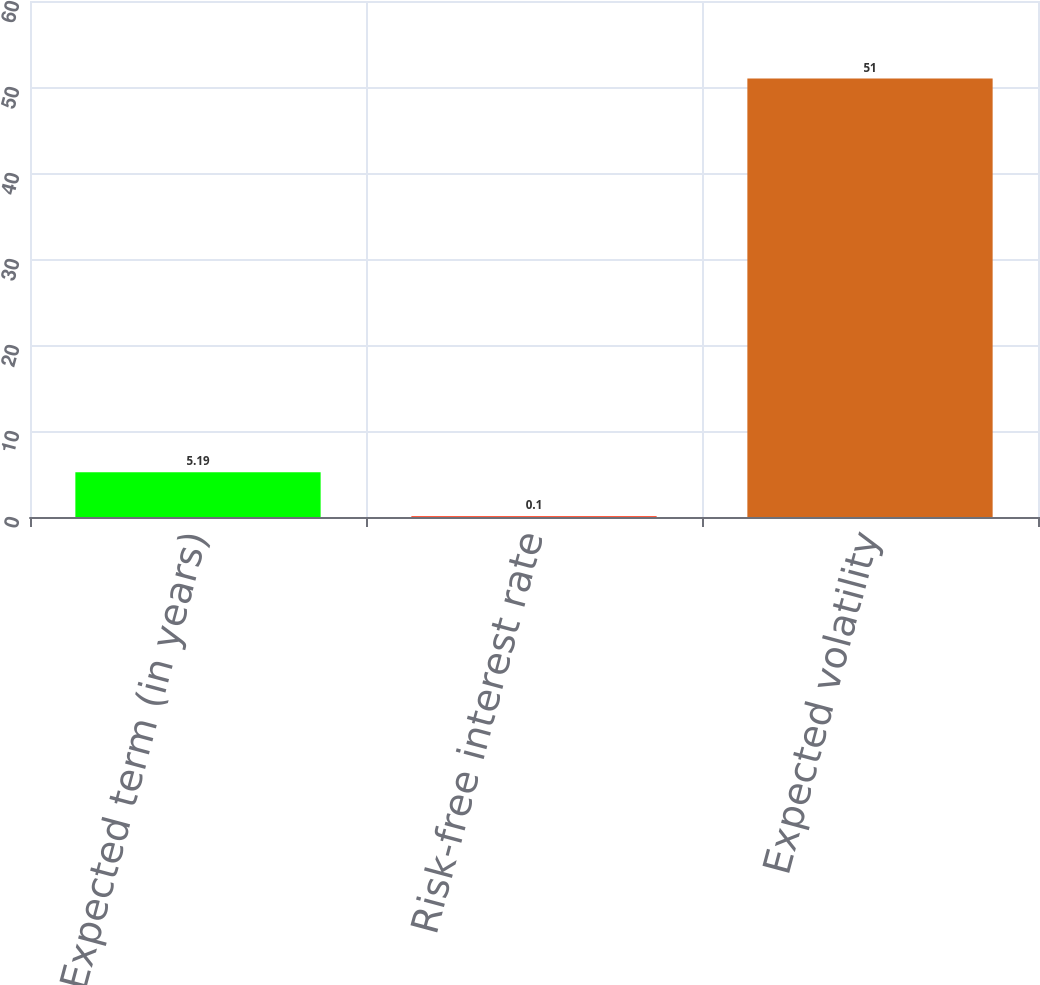Convert chart. <chart><loc_0><loc_0><loc_500><loc_500><bar_chart><fcel>Expected term (in years)<fcel>Risk-free interest rate<fcel>Expected volatility<nl><fcel>5.19<fcel>0.1<fcel>51<nl></chart> 